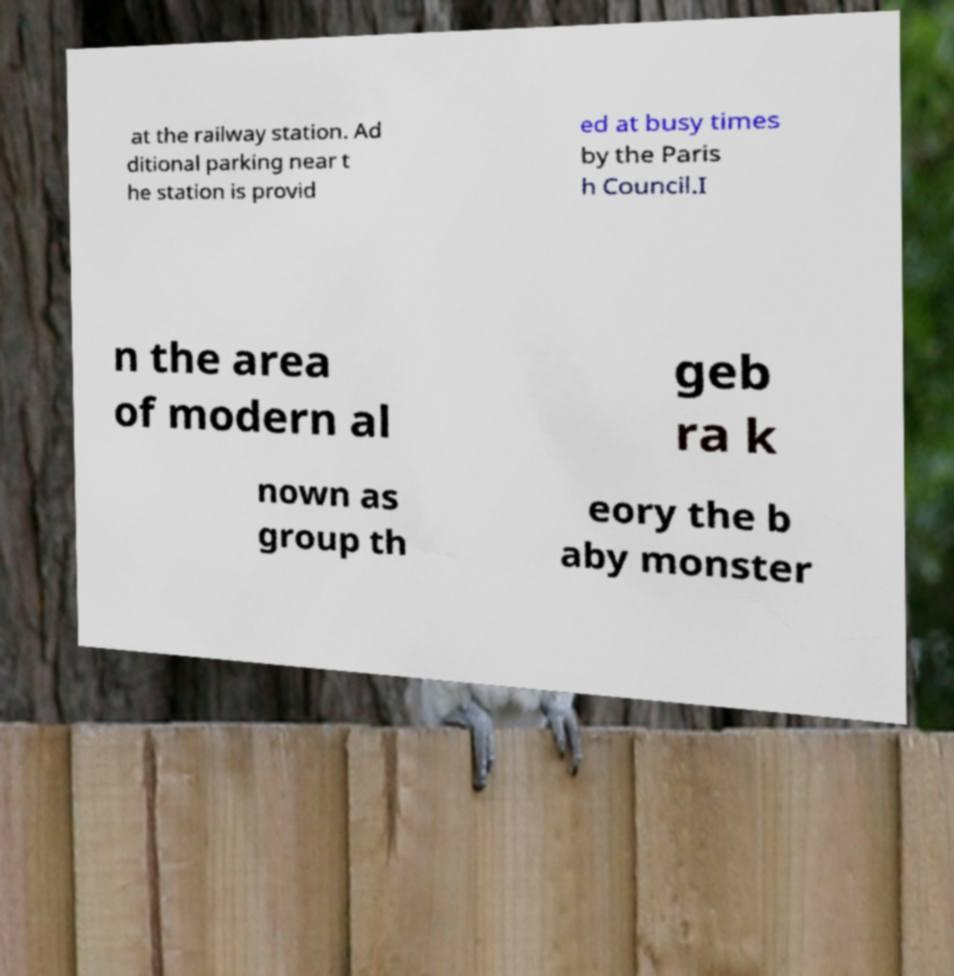Please identify and transcribe the text found in this image. at the railway station. Ad ditional parking near t he station is provid ed at busy times by the Paris h Council.I n the area of modern al geb ra k nown as group th eory the b aby monster 